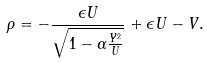<formula> <loc_0><loc_0><loc_500><loc_500>\rho = - \frac { \epsilon U } { \sqrt { 1 - \alpha \frac { Y ^ { 2 } } { U } } } + \epsilon U - V .</formula> 